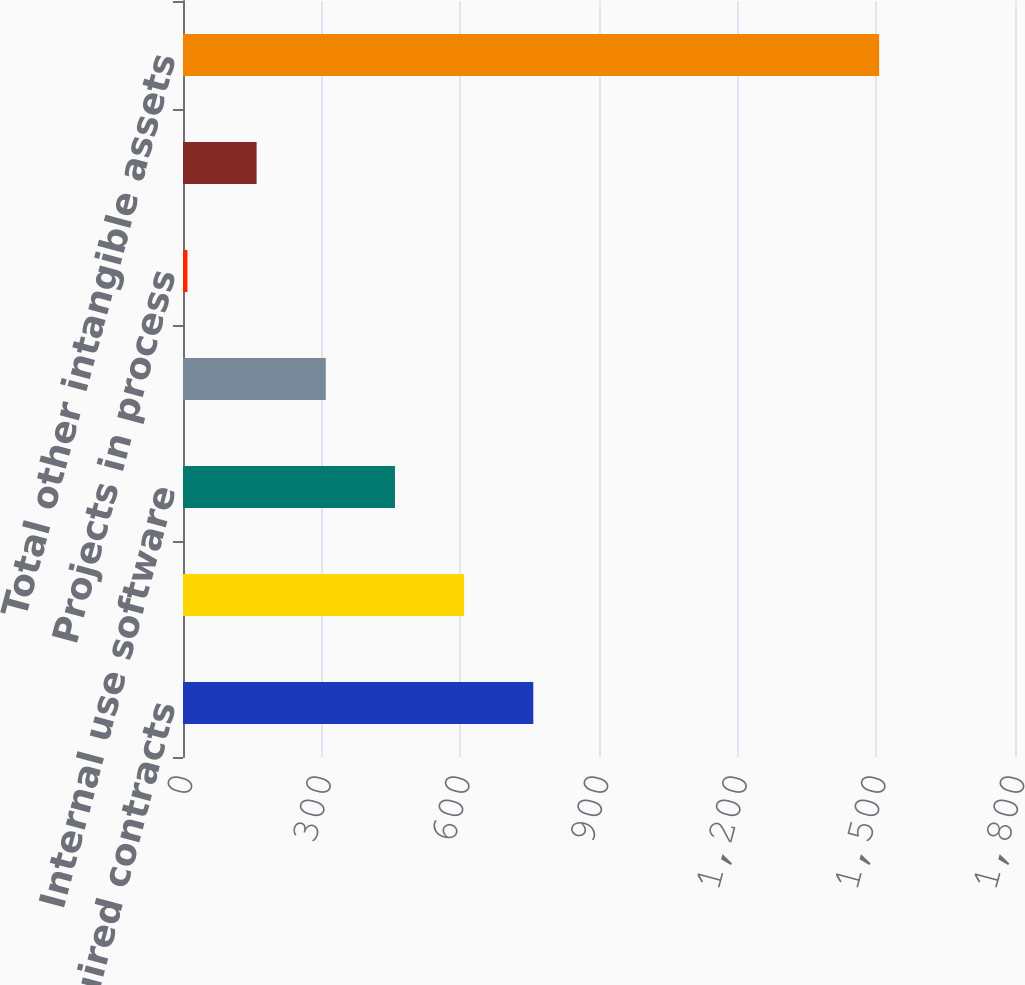Convert chart. <chart><loc_0><loc_0><loc_500><loc_500><bar_chart><fcel>Acquired contracts<fcel>Capitalized contract costs<fcel>Internal use software<fcel>Acquired trademarks<fcel>Projects in process<fcel>Other intangibles<fcel>Total other intangible assets<nl><fcel>757.85<fcel>608.2<fcel>458.55<fcel>308.9<fcel>9.6<fcel>159.25<fcel>1506.1<nl></chart> 